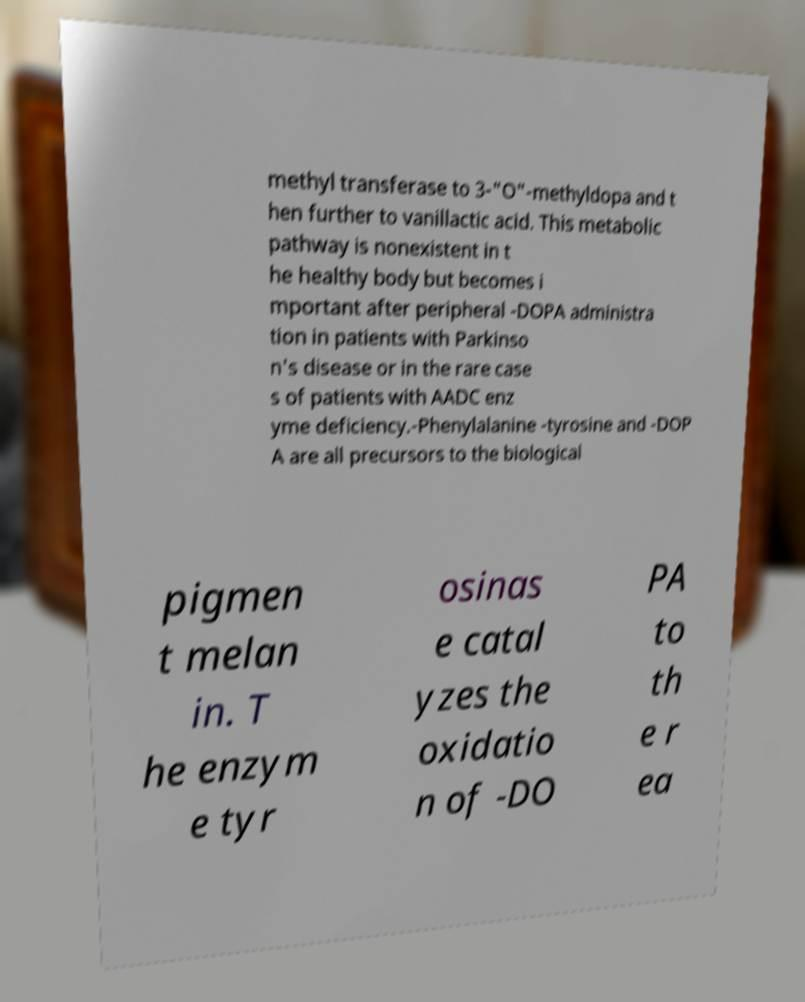Could you assist in decoding the text presented in this image and type it out clearly? methyl transferase to 3-"O"-methyldopa and t hen further to vanillactic acid. This metabolic pathway is nonexistent in t he healthy body but becomes i mportant after peripheral -DOPA administra tion in patients with Parkinso n's disease or in the rare case s of patients with AADC enz yme deficiency.-Phenylalanine -tyrosine and -DOP A are all precursors to the biological pigmen t melan in. T he enzym e tyr osinas e catal yzes the oxidatio n of -DO PA to th e r ea 